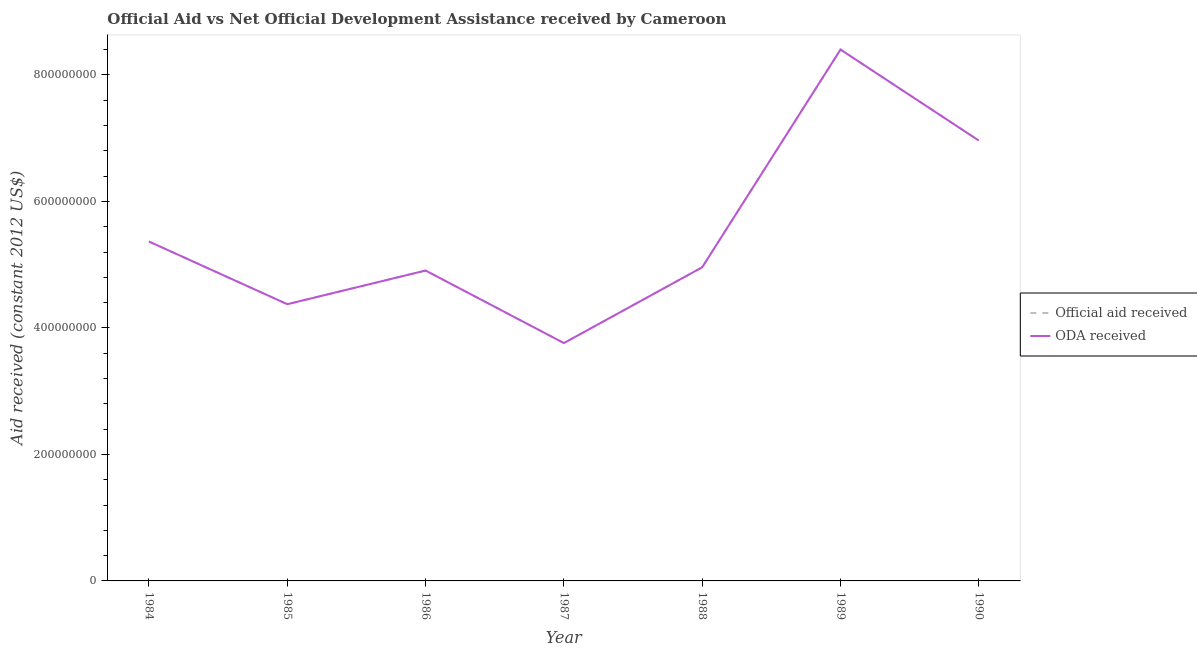What is the official aid received in 1987?
Your answer should be very brief. 3.76e+08. Across all years, what is the maximum official aid received?
Your answer should be very brief. 8.40e+08. Across all years, what is the minimum official aid received?
Give a very brief answer. 3.76e+08. In which year was the oda received maximum?
Offer a very short reply. 1989. In which year was the oda received minimum?
Give a very brief answer. 1987. What is the total official aid received in the graph?
Give a very brief answer. 3.87e+09. What is the difference between the official aid received in 1984 and that in 1990?
Provide a succinct answer. -1.60e+08. What is the difference between the official aid received in 1989 and the oda received in 1986?
Provide a short and direct response. 3.49e+08. What is the average oda received per year?
Ensure brevity in your answer.  5.53e+08. What is the ratio of the official aid received in 1986 to that in 1990?
Your response must be concise. 0.7. Is the difference between the oda received in 1984 and 1988 greater than the difference between the official aid received in 1984 and 1988?
Give a very brief answer. No. What is the difference between the highest and the second highest official aid received?
Your response must be concise. 1.44e+08. What is the difference between the highest and the lowest oda received?
Your answer should be very brief. 4.64e+08. In how many years, is the oda received greater than the average oda received taken over all years?
Give a very brief answer. 2. Is the oda received strictly greater than the official aid received over the years?
Provide a succinct answer. No. How many lines are there?
Your response must be concise. 2. Does the graph contain any zero values?
Ensure brevity in your answer.  No. What is the title of the graph?
Offer a terse response. Official Aid vs Net Official Development Assistance received by Cameroon . Does "Chemicals" appear as one of the legend labels in the graph?
Provide a succinct answer. No. What is the label or title of the X-axis?
Provide a short and direct response. Year. What is the label or title of the Y-axis?
Your answer should be compact. Aid received (constant 2012 US$). What is the Aid received (constant 2012 US$) in Official aid received in 1984?
Provide a succinct answer. 5.37e+08. What is the Aid received (constant 2012 US$) in ODA received in 1984?
Offer a very short reply. 5.37e+08. What is the Aid received (constant 2012 US$) in Official aid received in 1985?
Keep it short and to the point. 4.38e+08. What is the Aid received (constant 2012 US$) of ODA received in 1985?
Provide a succinct answer. 4.38e+08. What is the Aid received (constant 2012 US$) in Official aid received in 1986?
Your answer should be very brief. 4.91e+08. What is the Aid received (constant 2012 US$) in ODA received in 1986?
Your response must be concise. 4.91e+08. What is the Aid received (constant 2012 US$) of Official aid received in 1987?
Give a very brief answer. 3.76e+08. What is the Aid received (constant 2012 US$) of ODA received in 1987?
Provide a short and direct response. 3.76e+08. What is the Aid received (constant 2012 US$) of Official aid received in 1988?
Keep it short and to the point. 4.96e+08. What is the Aid received (constant 2012 US$) of ODA received in 1988?
Provide a succinct answer. 4.96e+08. What is the Aid received (constant 2012 US$) of Official aid received in 1989?
Ensure brevity in your answer.  8.40e+08. What is the Aid received (constant 2012 US$) in ODA received in 1989?
Your answer should be compact. 8.40e+08. What is the Aid received (constant 2012 US$) of Official aid received in 1990?
Offer a very short reply. 6.96e+08. What is the Aid received (constant 2012 US$) in ODA received in 1990?
Give a very brief answer. 6.96e+08. Across all years, what is the maximum Aid received (constant 2012 US$) in Official aid received?
Your answer should be very brief. 8.40e+08. Across all years, what is the maximum Aid received (constant 2012 US$) of ODA received?
Offer a very short reply. 8.40e+08. Across all years, what is the minimum Aid received (constant 2012 US$) in Official aid received?
Offer a terse response. 3.76e+08. Across all years, what is the minimum Aid received (constant 2012 US$) of ODA received?
Provide a short and direct response. 3.76e+08. What is the total Aid received (constant 2012 US$) of Official aid received in the graph?
Provide a succinct answer. 3.87e+09. What is the total Aid received (constant 2012 US$) of ODA received in the graph?
Offer a terse response. 3.87e+09. What is the difference between the Aid received (constant 2012 US$) in Official aid received in 1984 and that in 1985?
Provide a succinct answer. 9.91e+07. What is the difference between the Aid received (constant 2012 US$) in ODA received in 1984 and that in 1985?
Your answer should be compact. 9.91e+07. What is the difference between the Aid received (constant 2012 US$) in Official aid received in 1984 and that in 1986?
Offer a terse response. 4.59e+07. What is the difference between the Aid received (constant 2012 US$) in ODA received in 1984 and that in 1986?
Make the answer very short. 4.59e+07. What is the difference between the Aid received (constant 2012 US$) in Official aid received in 1984 and that in 1987?
Make the answer very short. 1.61e+08. What is the difference between the Aid received (constant 2012 US$) in ODA received in 1984 and that in 1987?
Ensure brevity in your answer.  1.61e+08. What is the difference between the Aid received (constant 2012 US$) of Official aid received in 1984 and that in 1988?
Your answer should be compact. 4.07e+07. What is the difference between the Aid received (constant 2012 US$) of ODA received in 1984 and that in 1988?
Make the answer very short. 4.07e+07. What is the difference between the Aid received (constant 2012 US$) of Official aid received in 1984 and that in 1989?
Ensure brevity in your answer.  -3.04e+08. What is the difference between the Aid received (constant 2012 US$) of ODA received in 1984 and that in 1989?
Ensure brevity in your answer.  -3.04e+08. What is the difference between the Aid received (constant 2012 US$) of Official aid received in 1984 and that in 1990?
Offer a terse response. -1.60e+08. What is the difference between the Aid received (constant 2012 US$) of ODA received in 1984 and that in 1990?
Make the answer very short. -1.60e+08. What is the difference between the Aid received (constant 2012 US$) in Official aid received in 1985 and that in 1986?
Your response must be concise. -5.32e+07. What is the difference between the Aid received (constant 2012 US$) in ODA received in 1985 and that in 1986?
Give a very brief answer. -5.32e+07. What is the difference between the Aid received (constant 2012 US$) of Official aid received in 1985 and that in 1987?
Offer a very short reply. 6.15e+07. What is the difference between the Aid received (constant 2012 US$) of ODA received in 1985 and that in 1987?
Provide a succinct answer. 6.15e+07. What is the difference between the Aid received (constant 2012 US$) in Official aid received in 1985 and that in 1988?
Provide a succinct answer. -5.84e+07. What is the difference between the Aid received (constant 2012 US$) in ODA received in 1985 and that in 1988?
Offer a very short reply. -5.84e+07. What is the difference between the Aid received (constant 2012 US$) in Official aid received in 1985 and that in 1989?
Provide a succinct answer. -4.03e+08. What is the difference between the Aid received (constant 2012 US$) in ODA received in 1985 and that in 1989?
Offer a very short reply. -4.03e+08. What is the difference between the Aid received (constant 2012 US$) in Official aid received in 1985 and that in 1990?
Your answer should be very brief. -2.59e+08. What is the difference between the Aid received (constant 2012 US$) of ODA received in 1985 and that in 1990?
Give a very brief answer. -2.59e+08. What is the difference between the Aid received (constant 2012 US$) in Official aid received in 1986 and that in 1987?
Give a very brief answer. 1.15e+08. What is the difference between the Aid received (constant 2012 US$) of ODA received in 1986 and that in 1987?
Your answer should be very brief. 1.15e+08. What is the difference between the Aid received (constant 2012 US$) in Official aid received in 1986 and that in 1988?
Provide a short and direct response. -5.14e+06. What is the difference between the Aid received (constant 2012 US$) in ODA received in 1986 and that in 1988?
Provide a succinct answer. -5.14e+06. What is the difference between the Aid received (constant 2012 US$) of Official aid received in 1986 and that in 1989?
Provide a short and direct response. -3.49e+08. What is the difference between the Aid received (constant 2012 US$) in ODA received in 1986 and that in 1989?
Offer a terse response. -3.49e+08. What is the difference between the Aid received (constant 2012 US$) in Official aid received in 1986 and that in 1990?
Offer a terse response. -2.05e+08. What is the difference between the Aid received (constant 2012 US$) of ODA received in 1986 and that in 1990?
Ensure brevity in your answer.  -2.05e+08. What is the difference between the Aid received (constant 2012 US$) of Official aid received in 1987 and that in 1988?
Offer a terse response. -1.20e+08. What is the difference between the Aid received (constant 2012 US$) in ODA received in 1987 and that in 1988?
Your answer should be compact. -1.20e+08. What is the difference between the Aid received (constant 2012 US$) of Official aid received in 1987 and that in 1989?
Your answer should be very brief. -4.64e+08. What is the difference between the Aid received (constant 2012 US$) in ODA received in 1987 and that in 1989?
Your answer should be compact. -4.64e+08. What is the difference between the Aid received (constant 2012 US$) of Official aid received in 1987 and that in 1990?
Keep it short and to the point. -3.20e+08. What is the difference between the Aid received (constant 2012 US$) of ODA received in 1987 and that in 1990?
Ensure brevity in your answer.  -3.20e+08. What is the difference between the Aid received (constant 2012 US$) in Official aid received in 1988 and that in 1989?
Give a very brief answer. -3.44e+08. What is the difference between the Aid received (constant 2012 US$) of ODA received in 1988 and that in 1989?
Provide a short and direct response. -3.44e+08. What is the difference between the Aid received (constant 2012 US$) in Official aid received in 1988 and that in 1990?
Your answer should be very brief. -2.00e+08. What is the difference between the Aid received (constant 2012 US$) in ODA received in 1988 and that in 1990?
Offer a terse response. -2.00e+08. What is the difference between the Aid received (constant 2012 US$) in Official aid received in 1989 and that in 1990?
Your answer should be compact. 1.44e+08. What is the difference between the Aid received (constant 2012 US$) of ODA received in 1989 and that in 1990?
Offer a very short reply. 1.44e+08. What is the difference between the Aid received (constant 2012 US$) in Official aid received in 1984 and the Aid received (constant 2012 US$) in ODA received in 1985?
Ensure brevity in your answer.  9.91e+07. What is the difference between the Aid received (constant 2012 US$) of Official aid received in 1984 and the Aid received (constant 2012 US$) of ODA received in 1986?
Offer a very short reply. 4.59e+07. What is the difference between the Aid received (constant 2012 US$) in Official aid received in 1984 and the Aid received (constant 2012 US$) in ODA received in 1987?
Ensure brevity in your answer.  1.61e+08. What is the difference between the Aid received (constant 2012 US$) of Official aid received in 1984 and the Aid received (constant 2012 US$) of ODA received in 1988?
Give a very brief answer. 4.07e+07. What is the difference between the Aid received (constant 2012 US$) of Official aid received in 1984 and the Aid received (constant 2012 US$) of ODA received in 1989?
Offer a very short reply. -3.04e+08. What is the difference between the Aid received (constant 2012 US$) of Official aid received in 1984 and the Aid received (constant 2012 US$) of ODA received in 1990?
Your answer should be compact. -1.60e+08. What is the difference between the Aid received (constant 2012 US$) in Official aid received in 1985 and the Aid received (constant 2012 US$) in ODA received in 1986?
Offer a terse response. -5.32e+07. What is the difference between the Aid received (constant 2012 US$) in Official aid received in 1985 and the Aid received (constant 2012 US$) in ODA received in 1987?
Provide a succinct answer. 6.15e+07. What is the difference between the Aid received (constant 2012 US$) in Official aid received in 1985 and the Aid received (constant 2012 US$) in ODA received in 1988?
Your answer should be compact. -5.84e+07. What is the difference between the Aid received (constant 2012 US$) of Official aid received in 1985 and the Aid received (constant 2012 US$) of ODA received in 1989?
Give a very brief answer. -4.03e+08. What is the difference between the Aid received (constant 2012 US$) in Official aid received in 1985 and the Aid received (constant 2012 US$) in ODA received in 1990?
Make the answer very short. -2.59e+08. What is the difference between the Aid received (constant 2012 US$) of Official aid received in 1986 and the Aid received (constant 2012 US$) of ODA received in 1987?
Offer a very short reply. 1.15e+08. What is the difference between the Aid received (constant 2012 US$) in Official aid received in 1986 and the Aid received (constant 2012 US$) in ODA received in 1988?
Offer a terse response. -5.14e+06. What is the difference between the Aid received (constant 2012 US$) of Official aid received in 1986 and the Aid received (constant 2012 US$) of ODA received in 1989?
Offer a terse response. -3.49e+08. What is the difference between the Aid received (constant 2012 US$) of Official aid received in 1986 and the Aid received (constant 2012 US$) of ODA received in 1990?
Your answer should be very brief. -2.05e+08. What is the difference between the Aid received (constant 2012 US$) of Official aid received in 1987 and the Aid received (constant 2012 US$) of ODA received in 1988?
Provide a short and direct response. -1.20e+08. What is the difference between the Aid received (constant 2012 US$) in Official aid received in 1987 and the Aid received (constant 2012 US$) in ODA received in 1989?
Your answer should be compact. -4.64e+08. What is the difference between the Aid received (constant 2012 US$) in Official aid received in 1987 and the Aid received (constant 2012 US$) in ODA received in 1990?
Ensure brevity in your answer.  -3.20e+08. What is the difference between the Aid received (constant 2012 US$) of Official aid received in 1988 and the Aid received (constant 2012 US$) of ODA received in 1989?
Your answer should be compact. -3.44e+08. What is the difference between the Aid received (constant 2012 US$) of Official aid received in 1988 and the Aid received (constant 2012 US$) of ODA received in 1990?
Provide a short and direct response. -2.00e+08. What is the difference between the Aid received (constant 2012 US$) of Official aid received in 1989 and the Aid received (constant 2012 US$) of ODA received in 1990?
Your answer should be compact. 1.44e+08. What is the average Aid received (constant 2012 US$) of Official aid received per year?
Give a very brief answer. 5.53e+08. What is the average Aid received (constant 2012 US$) in ODA received per year?
Offer a terse response. 5.53e+08. In the year 1988, what is the difference between the Aid received (constant 2012 US$) in Official aid received and Aid received (constant 2012 US$) in ODA received?
Offer a very short reply. 0. In the year 1989, what is the difference between the Aid received (constant 2012 US$) in Official aid received and Aid received (constant 2012 US$) in ODA received?
Offer a very short reply. 0. In the year 1990, what is the difference between the Aid received (constant 2012 US$) of Official aid received and Aid received (constant 2012 US$) of ODA received?
Provide a short and direct response. 0. What is the ratio of the Aid received (constant 2012 US$) of Official aid received in 1984 to that in 1985?
Offer a very short reply. 1.23. What is the ratio of the Aid received (constant 2012 US$) of ODA received in 1984 to that in 1985?
Your response must be concise. 1.23. What is the ratio of the Aid received (constant 2012 US$) in Official aid received in 1984 to that in 1986?
Make the answer very short. 1.09. What is the ratio of the Aid received (constant 2012 US$) of ODA received in 1984 to that in 1986?
Provide a short and direct response. 1.09. What is the ratio of the Aid received (constant 2012 US$) of Official aid received in 1984 to that in 1987?
Give a very brief answer. 1.43. What is the ratio of the Aid received (constant 2012 US$) in ODA received in 1984 to that in 1987?
Make the answer very short. 1.43. What is the ratio of the Aid received (constant 2012 US$) of Official aid received in 1984 to that in 1988?
Offer a very short reply. 1.08. What is the ratio of the Aid received (constant 2012 US$) in ODA received in 1984 to that in 1988?
Make the answer very short. 1.08. What is the ratio of the Aid received (constant 2012 US$) in Official aid received in 1984 to that in 1989?
Provide a short and direct response. 0.64. What is the ratio of the Aid received (constant 2012 US$) in ODA received in 1984 to that in 1989?
Offer a terse response. 0.64. What is the ratio of the Aid received (constant 2012 US$) of Official aid received in 1984 to that in 1990?
Offer a very short reply. 0.77. What is the ratio of the Aid received (constant 2012 US$) in ODA received in 1984 to that in 1990?
Your answer should be compact. 0.77. What is the ratio of the Aid received (constant 2012 US$) in Official aid received in 1985 to that in 1986?
Provide a succinct answer. 0.89. What is the ratio of the Aid received (constant 2012 US$) of ODA received in 1985 to that in 1986?
Offer a terse response. 0.89. What is the ratio of the Aid received (constant 2012 US$) of Official aid received in 1985 to that in 1987?
Provide a succinct answer. 1.16. What is the ratio of the Aid received (constant 2012 US$) in ODA received in 1985 to that in 1987?
Offer a very short reply. 1.16. What is the ratio of the Aid received (constant 2012 US$) of Official aid received in 1985 to that in 1988?
Offer a terse response. 0.88. What is the ratio of the Aid received (constant 2012 US$) in ODA received in 1985 to that in 1988?
Make the answer very short. 0.88. What is the ratio of the Aid received (constant 2012 US$) in Official aid received in 1985 to that in 1989?
Your response must be concise. 0.52. What is the ratio of the Aid received (constant 2012 US$) in ODA received in 1985 to that in 1989?
Ensure brevity in your answer.  0.52. What is the ratio of the Aid received (constant 2012 US$) in Official aid received in 1985 to that in 1990?
Provide a succinct answer. 0.63. What is the ratio of the Aid received (constant 2012 US$) in ODA received in 1985 to that in 1990?
Your response must be concise. 0.63. What is the ratio of the Aid received (constant 2012 US$) in Official aid received in 1986 to that in 1987?
Give a very brief answer. 1.3. What is the ratio of the Aid received (constant 2012 US$) of ODA received in 1986 to that in 1987?
Your answer should be very brief. 1.3. What is the ratio of the Aid received (constant 2012 US$) of ODA received in 1986 to that in 1988?
Offer a very short reply. 0.99. What is the ratio of the Aid received (constant 2012 US$) in Official aid received in 1986 to that in 1989?
Provide a succinct answer. 0.58. What is the ratio of the Aid received (constant 2012 US$) of ODA received in 1986 to that in 1989?
Your answer should be compact. 0.58. What is the ratio of the Aid received (constant 2012 US$) of Official aid received in 1986 to that in 1990?
Give a very brief answer. 0.7. What is the ratio of the Aid received (constant 2012 US$) in ODA received in 1986 to that in 1990?
Provide a succinct answer. 0.7. What is the ratio of the Aid received (constant 2012 US$) of Official aid received in 1987 to that in 1988?
Your answer should be compact. 0.76. What is the ratio of the Aid received (constant 2012 US$) in ODA received in 1987 to that in 1988?
Ensure brevity in your answer.  0.76. What is the ratio of the Aid received (constant 2012 US$) in Official aid received in 1987 to that in 1989?
Provide a succinct answer. 0.45. What is the ratio of the Aid received (constant 2012 US$) of ODA received in 1987 to that in 1989?
Your response must be concise. 0.45. What is the ratio of the Aid received (constant 2012 US$) of Official aid received in 1987 to that in 1990?
Your answer should be compact. 0.54. What is the ratio of the Aid received (constant 2012 US$) in ODA received in 1987 to that in 1990?
Your response must be concise. 0.54. What is the ratio of the Aid received (constant 2012 US$) of Official aid received in 1988 to that in 1989?
Provide a short and direct response. 0.59. What is the ratio of the Aid received (constant 2012 US$) in ODA received in 1988 to that in 1989?
Ensure brevity in your answer.  0.59. What is the ratio of the Aid received (constant 2012 US$) of Official aid received in 1988 to that in 1990?
Keep it short and to the point. 0.71. What is the ratio of the Aid received (constant 2012 US$) of ODA received in 1988 to that in 1990?
Ensure brevity in your answer.  0.71. What is the ratio of the Aid received (constant 2012 US$) of Official aid received in 1989 to that in 1990?
Ensure brevity in your answer.  1.21. What is the ratio of the Aid received (constant 2012 US$) of ODA received in 1989 to that in 1990?
Your answer should be very brief. 1.21. What is the difference between the highest and the second highest Aid received (constant 2012 US$) of Official aid received?
Your response must be concise. 1.44e+08. What is the difference between the highest and the second highest Aid received (constant 2012 US$) of ODA received?
Keep it short and to the point. 1.44e+08. What is the difference between the highest and the lowest Aid received (constant 2012 US$) of Official aid received?
Make the answer very short. 4.64e+08. What is the difference between the highest and the lowest Aid received (constant 2012 US$) in ODA received?
Offer a terse response. 4.64e+08. 